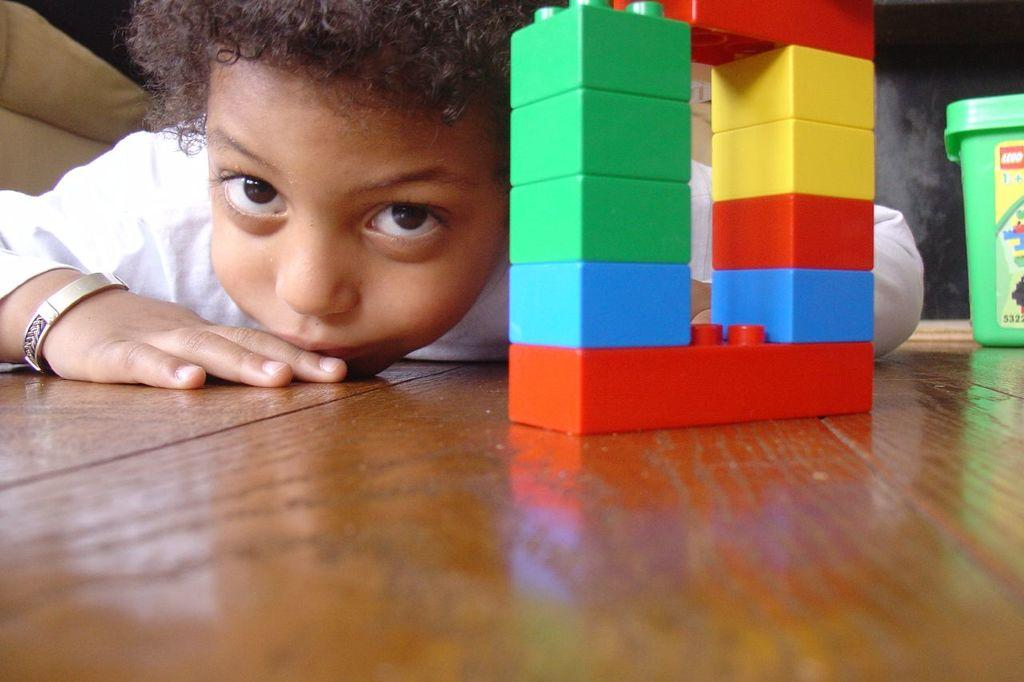What type of toy is present in the image? There are lego bricks in the image. What is the surface made of that the lego bricks are on? The lego bricks are on a wooden surface. Who is in the image? There is a child in the image. What color is the box in the image? There is a green box in the image. What type of fowl can be seen in the image? There is no fowl present in the image. How many crackers are visible in the image? There are no crackers present in the image. 